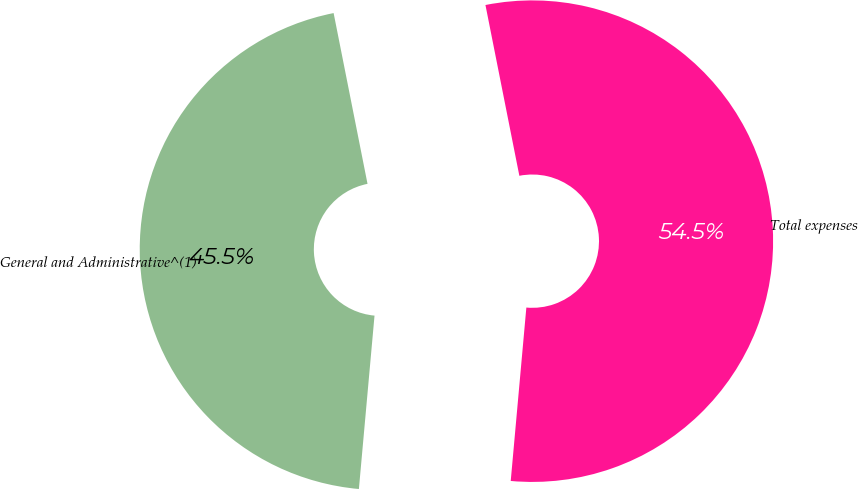Convert chart. <chart><loc_0><loc_0><loc_500><loc_500><pie_chart><fcel>General and Administrative^(1)<fcel>Total expenses<nl><fcel>45.45%<fcel>54.55%<nl></chart> 